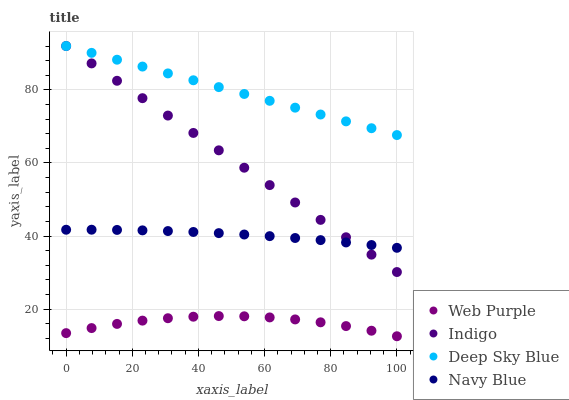Does Web Purple have the minimum area under the curve?
Answer yes or no. Yes. Does Deep Sky Blue have the maximum area under the curve?
Answer yes or no. Yes. Does Indigo have the minimum area under the curve?
Answer yes or no. No. Does Indigo have the maximum area under the curve?
Answer yes or no. No. Is Indigo the smoothest?
Answer yes or no. Yes. Is Web Purple the roughest?
Answer yes or no. Yes. Is Web Purple the smoothest?
Answer yes or no. No. Is Indigo the roughest?
Answer yes or no. No. Does Web Purple have the lowest value?
Answer yes or no. Yes. Does Indigo have the lowest value?
Answer yes or no. No. Does Deep Sky Blue have the highest value?
Answer yes or no. Yes. Does Web Purple have the highest value?
Answer yes or no. No. Is Web Purple less than Indigo?
Answer yes or no. Yes. Is Deep Sky Blue greater than Navy Blue?
Answer yes or no. Yes. Does Deep Sky Blue intersect Indigo?
Answer yes or no. Yes. Is Deep Sky Blue less than Indigo?
Answer yes or no. No. Is Deep Sky Blue greater than Indigo?
Answer yes or no. No. Does Web Purple intersect Indigo?
Answer yes or no. No. 